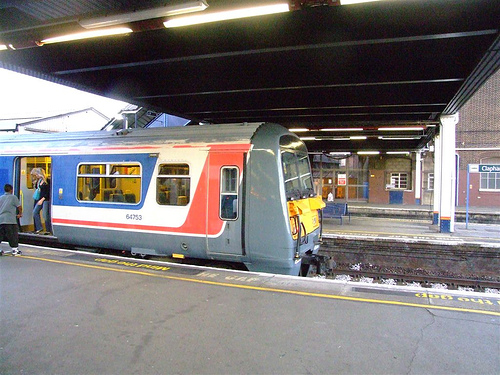How many people are near the train? There appears to be one person standing near the train, positioned by the open door and possibly preparing to board or having just disembarked. 